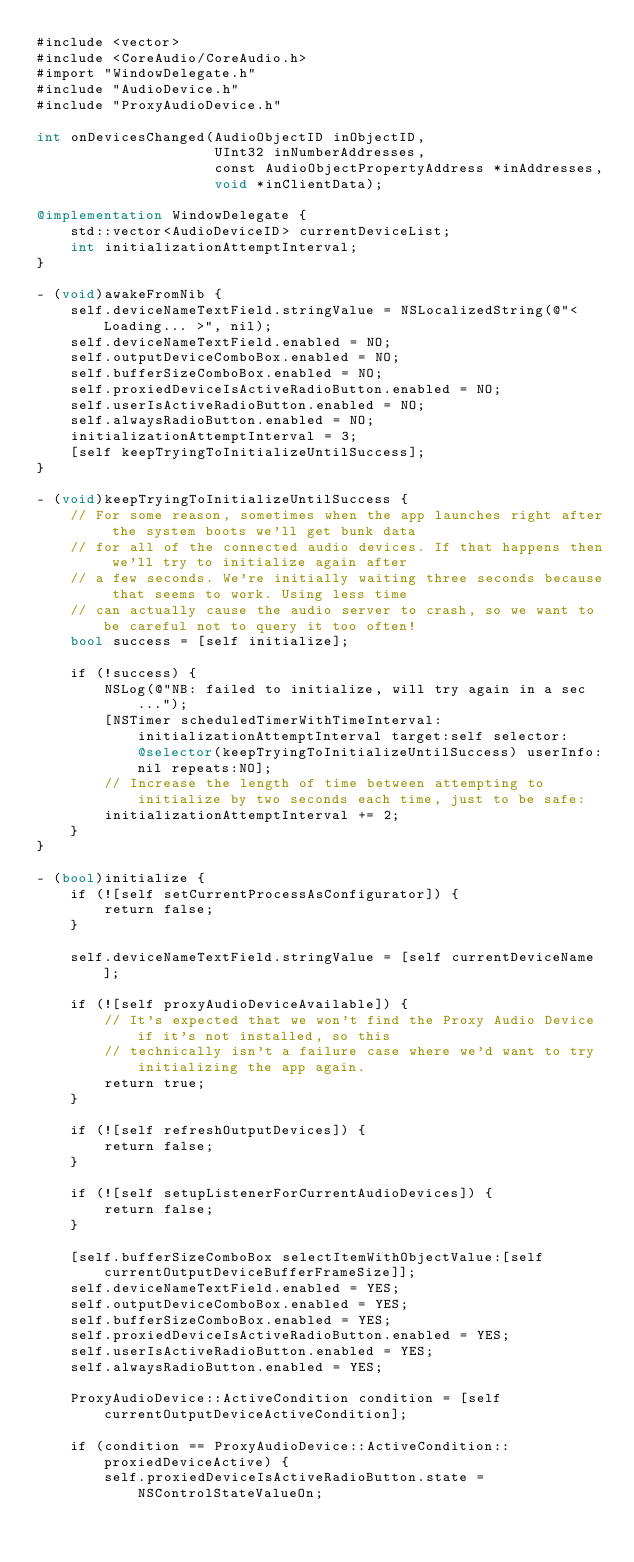<code> <loc_0><loc_0><loc_500><loc_500><_ObjectiveC_>#include <vector>
#include <CoreAudio/CoreAudio.h>
#import "WindowDelegate.h"
#include "AudioDevice.h"
#include "ProxyAudioDevice.h"

int onDevicesChanged(AudioObjectID inObjectID,
                     UInt32 inNumberAddresses,
                     const AudioObjectPropertyAddress *inAddresses,
                     void *inClientData);

@implementation WindowDelegate {
    std::vector<AudioDeviceID> currentDeviceList;
    int initializationAttemptInterval;
}

- (void)awakeFromNib {
    self.deviceNameTextField.stringValue = NSLocalizedString(@"< Loading... >", nil);
    self.deviceNameTextField.enabled = NO;
    self.outputDeviceComboBox.enabled = NO;
    self.bufferSizeComboBox.enabled = NO;
    self.proxiedDeviceIsActiveRadioButton.enabled = NO;
    self.userIsActiveRadioButton.enabled = NO;
    self.alwaysRadioButton.enabled = NO;
    initializationAttemptInterval = 3;
    [self keepTryingToInitializeUntilSuccess];
}

- (void)keepTryingToInitializeUntilSuccess {
    // For some reason, sometimes when the app launches right after the system boots we'll get bunk data
    // for all of the connected audio devices. If that happens then we'll try to initialize again after
    // a few seconds. We're initially waiting three seconds because that seems to work. Using less time
    // can actually cause the audio server to crash, so we want to be careful not to query it too often!
    bool success = [self initialize];
    
    if (!success) {
        NSLog(@"NB: failed to initialize, will try again in a sec...");
        [NSTimer scheduledTimerWithTimeInterval:initializationAttemptInterval target:self selector:@selector(keepTryingToInitializeUntilSuccess) userInfo:nil repeats:NO];
        // Increase the length of time between attempting to initialize by two seconds each time, just to be safe:
        initializationAttemptInterval += 2;
    }
}

- (bool)initialize {
    if (![self setCurrentProcessAsConfigurator]) {
        return false;
    }
    
    self.deviceNameTextField.stringValue = [self currentDeviceName];
    
    if (![self proxyAudioDeviceAvailable]) {
        // It's expected that we won't find the Proxy Audio Device if it's not installed, so this
        // technically isn't a failure case where we'd want to try initializing the app again.
        return true;
    }
    
    if (![self refreshOutputDevices]) {
        return false;
    }
    
    if (![self setupListenerForCurrentAudioDevices]) {
        return false;
    }
    
    [self.bufferSizeComboBox selectItemWithObjectValue:[self currentOutputDeviceBufferFrameSize]];
    self.deviceNameTextField.enabled = YES;
    self.outputDeviceComboBox.enabled = YES;
    self.bufferSizeComboBox.enabled = YES;
    self.proxiedDeviceIsActiveRadioButton.enabled = YES;
    self.userIsActiveRadioButton.enabled = YES;
    self.alwaysRadioButton.enabled = YES;

    ProxyAudioDevice::ActiveCondition condition = [self currentOutputDeviceActiveCondition];

    if (condition == ProxyAudioDevice::ActiveCondition::proxiedDeviceActive) {
        self.proxiedDeviceIsActiveRadioButton.state = NSControlStateValueOn;</code> 